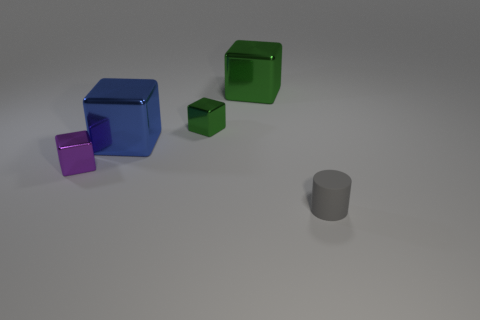What number of objects are in front of the big blue shiny thing and on the left side of the tiny cylinder?
Offer a very short reply. 1. How many metal objects are green things or gray things?
Offer a very short reply. 2. What material is the big thing that is right of the small shiny block that is to the right of the object that is left of the blue object?
Offer a terse response. Metal. There is a tiny thing that is on the right side of the small block that is behind the purple cube; what is its material?
Ensure brevity in your answer.  Rubber. There is a object in front of the purple metallic block; does it have the same size as the blue block that is right of the purple metal object?
Keep it short and to the point. No. Is there anything else that has the same material as the big green thing?
Give a very brief answer. Yes. How many big objects are either yellow metal cylinders or gray cylinders?
Your answer should be compact. 0. What number of objects are either small blocks that are left of the big blue metal thing or green metal cubes?
Provide a short and direct response. 3. What number of other things are the same shape as the gray matte object?
Your answer should be very brief. 0. How many gray things are either cylinders or big metallic things?
Provide a succinct answer. 1. 